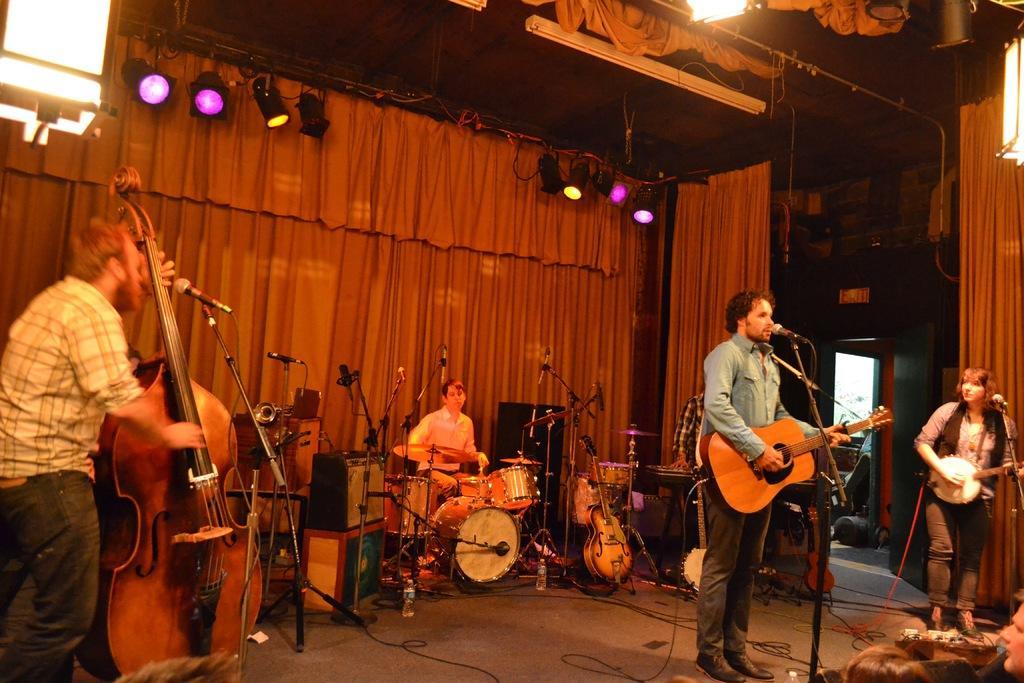Please provide a concise description of this image. This is a place where a group of people holding and playing some musical instruments in front of the mics and the back curtain is red in color and there are some different color lights on the roof. 